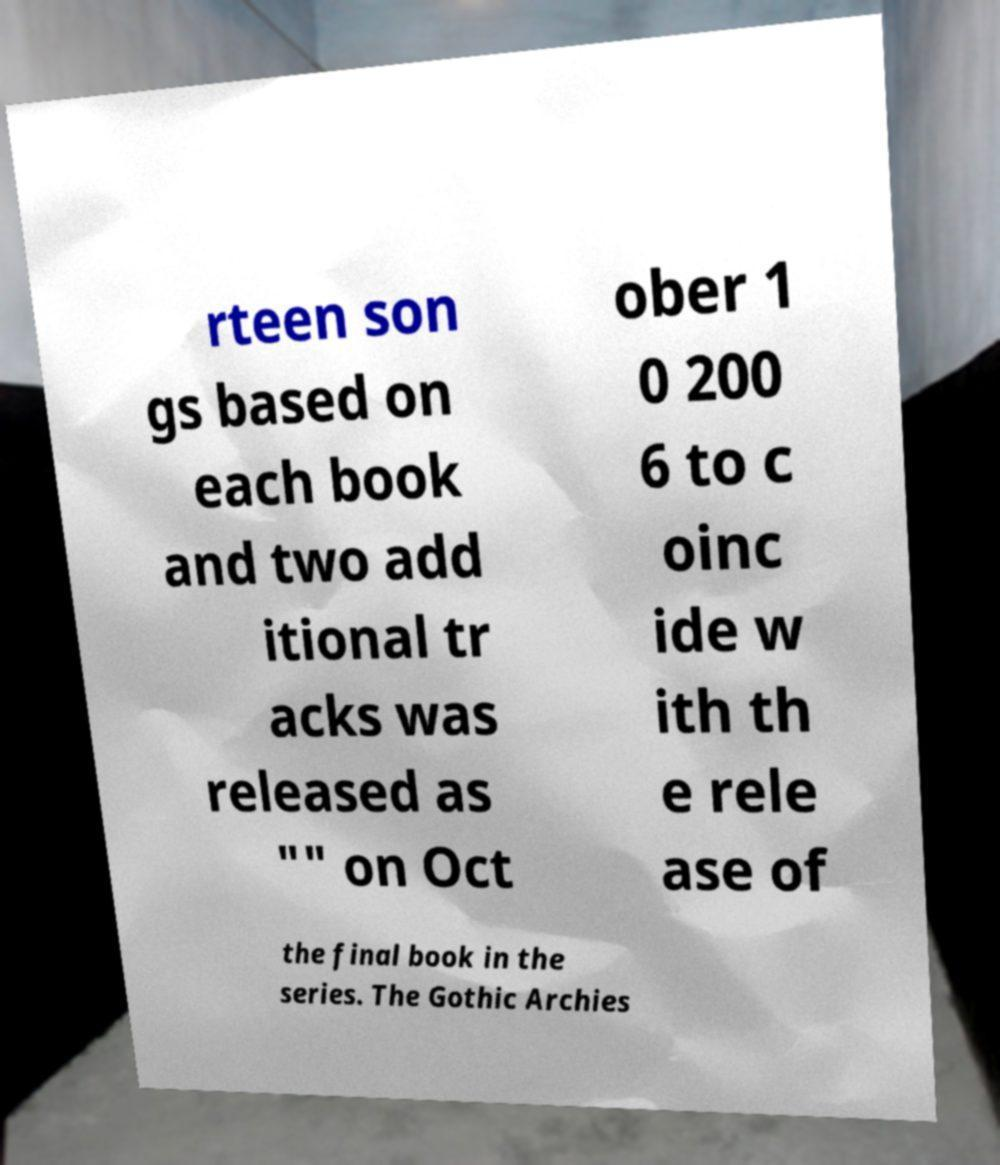For documentation purposes, I need the text within this image transcribed. Could you provide that? rteen son gs based on each book and two add itional tr acks was released as "" on Oct ober 1 0 200 6 to c oinc ide w ith th e rele ase of the final book in the series. The Gothic Archies 